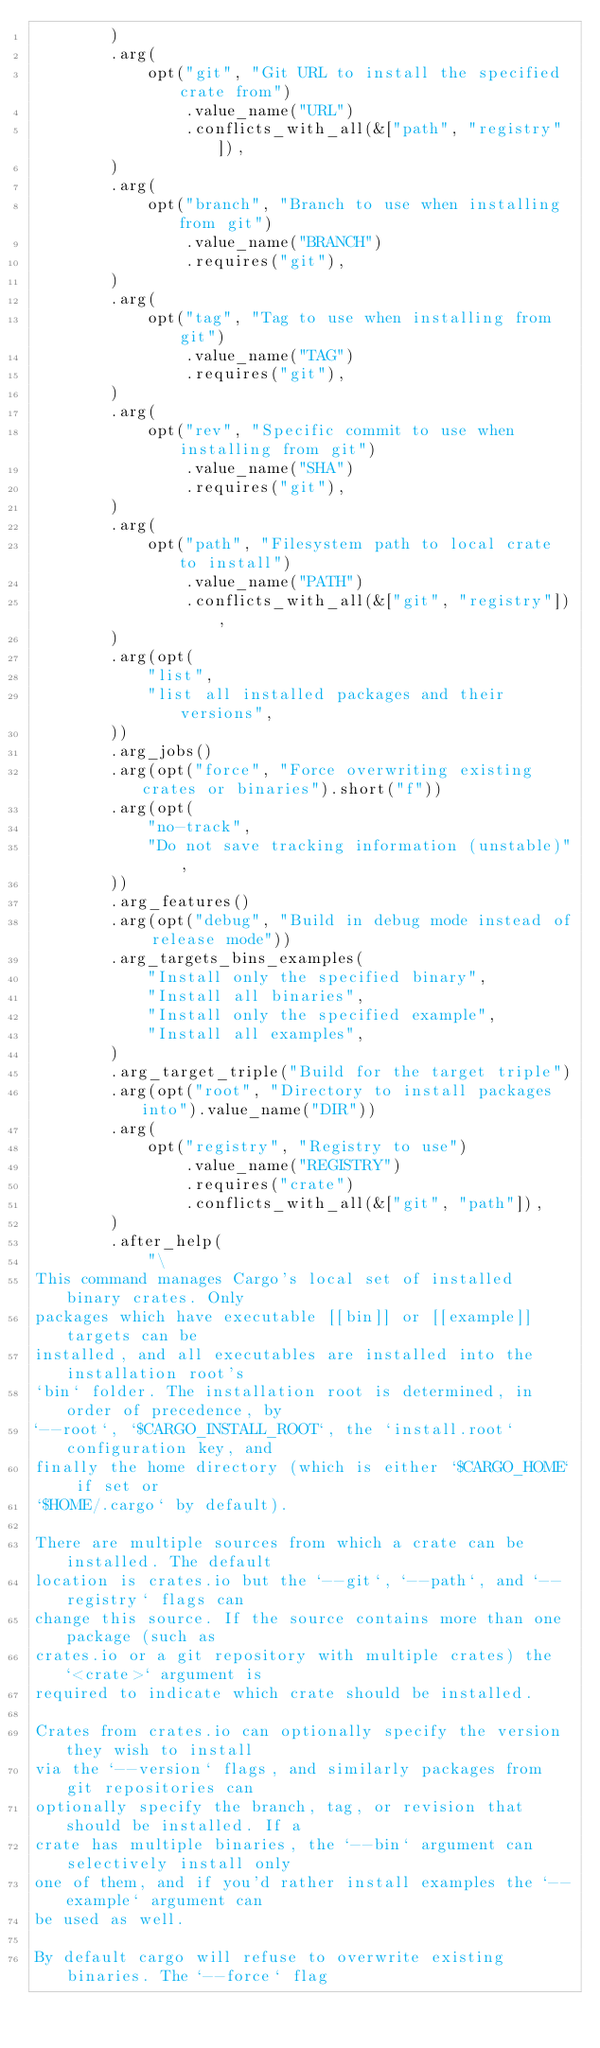<code> <loc_0><loc_0><loc_500><loc_500><_Rust_>        )
        .arg(
            opt("git", "Git URL to install the specified crate from")
                .value_name("URL")
                .conflicts_with_all(&["path", "registry"]),
        )
        .arg(
            opt("branch", "Branch to use when installing from git")
                .value_name("BRANCH")
                .requires("git"),
        )
        .arg(
            opt("tag", "Tag to use when installing from git")
                .value_name("TAG")
                .requires("git"),
        )
        .arg(
            opt("rev", "Specific commit to use when installing from git")
                .value_name("SHA")
                .requires("git"),
        )
        .arg(
            opt("path", "Filesystem path to local crate to install")
                .value_name("PATH")
                .conflicts_with_all(&["git", "registry"]),
        )
        .arg(opt(
            "list",
            "list all installed packages and their versions",
        ))
        .arg_jobs()
        .arg(opt("force", "Force overwriting existing crates or binaries").short("f"))
        .arg(opt(
            "no-track",
            "Do not save tracking information (unstable)",
        ))
        .arg_features()
        .arg(opt("debug", "Build in debug mode instead of release mode"))
        .arg_targets_bins_examples(
            "Install only the specified binary",
            "Install all binaries",
            "Install only the specified example",
            "Install all examples",
        )
        .arg_target_triple("Build for the target triple")
        .arg(opt("root", "Directory to install packages into").value_name("DIR"))
        .arg(
            opt("registry", "Registry to use")
                .value_name("REGISTRY")
                .requires("crate")
                .conflicts_with_all(&["git", "path"]),
        )
        .after_help(
            "\
This command manages Cargo's local set of installed binary crates. Only
packages which have executable [[bin]] or [[example]] targets can be
installed, and all executables are installed into the installation root's
`bin` folder. The installation root is determined, in order of precedence, by
`--root`, `$CARGO_INSTALL_ROOT`, the `install.root` configuration key, and
finally the home directory (which is either `$CARGO_HOME` if set or
`$HOME/.cargo` by default).

There are multiple sources from which a crate can be installed. The default
location is crates.io but the `--git`, `--path`, and `--registry` flags can
change this source. If the source contains more than one package (such as
crates.io or a git repository with multiple crates) the `<crate>` argument is
required to indicate which crate should be installed.

Crates from crates.io can optionally specify the version they wish to install
via the `--version` flags, and similarly packages from git repositories can
optionally specify the branch, tag, or revision that should be installed. If a
crate has multiple binaries, the `--bin` argument can selectively install only
one of them, and if you'd rather install examples the `--example` argument can
be used as well.

By default cargo will refuse to overwrite existing binaries. The `--force` flag</code> 